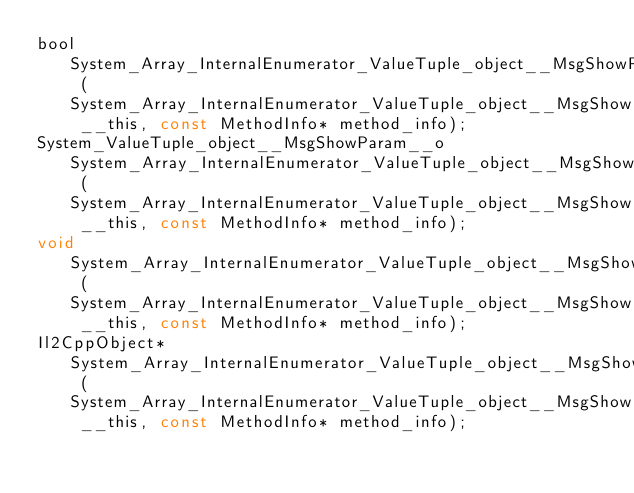<code> <loc_0><loc_0><loc_500><loc_500><_C_>bool System_Array_InternalEnumerator_ValueTuple_object__MsgShowParam____MoveNext (System_Array_InternalEnumerator_ValueTuple_object__MsgShowParam___o __this, const MethodInfo* method_info);
System_ValueTuple_object__MsgShowParam__o System_Array_InternalEnumerator_ValueTuple_object__MsgShowParam____get_Current (System_Array_InternalEnumerator_ValueTuple_object__MsgShowParam___o __this, const MethodInfo* method_info);
void System_Array_InternalEnumerator_ValueTuple_object__MsgShowParam____System_Collections_IEnumerator_Reset (System_Array_InternalEnumerator_ValueTuple_object__MsgShowParam___o __this, const MethodInfo* method_info);
Il2CppObject* System_Array_InternalEnumerator_ValueTuple_object__MsgShowParam____System_Collections_IEnumerator_get_Current (System_Array_InternalEnumerator_ValueTuple_object__MsgShowParam___o __this, const MethodInfo* method_info);
</code> 